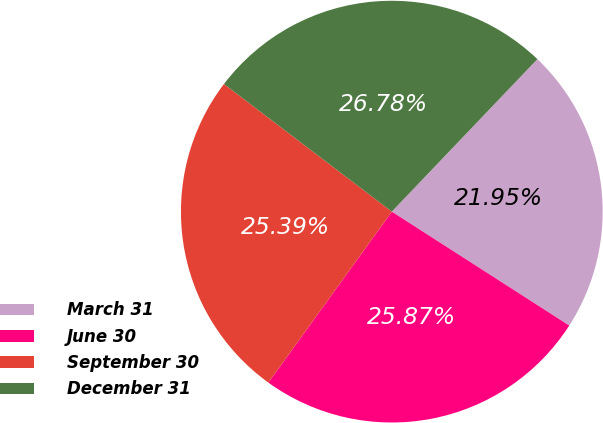Convert chart to OTSL. <chart><loc_0><loc_0><loc_500><loc_500><pie_chart><fcel>March 31<fcel>June 30<fcel>September 30<fcel>December 31<nl><fcel>21.95%<fcel>25.87%<fcel>25.39%<fcel>26.78%<nl></chart> 